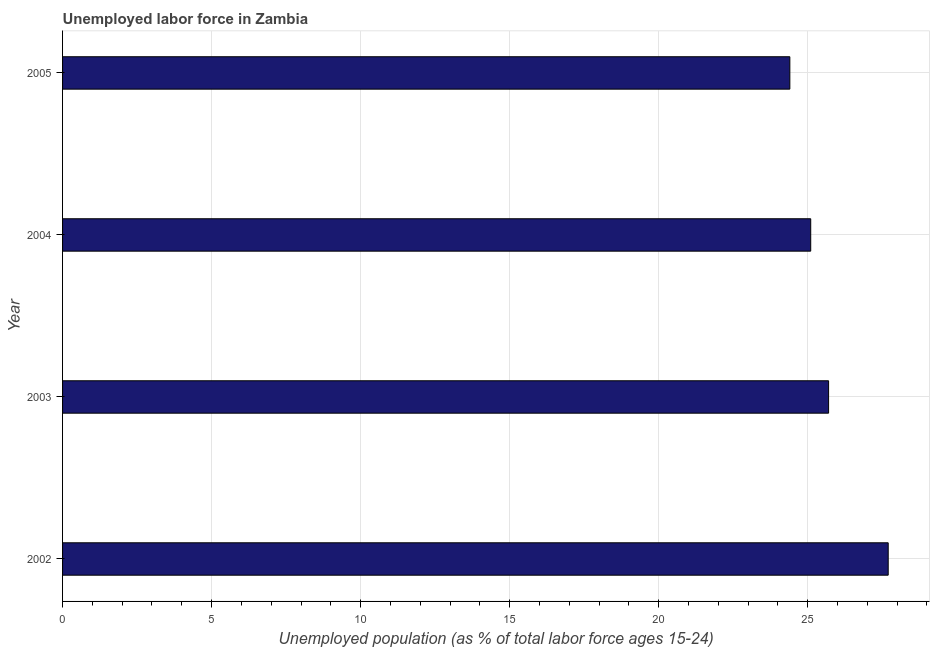Does the graph contain any zero values?
Give a very brief answer. No. What is the title of the graph?
Your response must be concise. Unemployed labor force in Zambia. What is the label or title of the X-axis?
Your answer should be very brief. Unemployed population (as % of total labor force ages 15-24). What is the total unemployed youth population in 2004?
Your answer should be compact. 25.1. Across all years, what is the maximum total unemployed youth population?
Make the answer very short. 27.7. Across all years, what is the minimum total unemployed youth population?
Offer a terse response. 24.4. What is the sum of the total unemployed youth population?
Your answer should be very brief. 102.9. What is the average total unemployed youth population per year?
Provide a succinct answer. 25.73. What is the median total unemployed youth population?
Your answer should be compact. 25.4. Do a majority of the years between 2002 and 2004 (inclusive) have total unemployed youth population greater than 19 %?
Provide a short and direct response. Yes. Is the difference between the total unemployed youth population in 2003 and 2004 greater than the difference between any two years?
Keep it short and to the point. No. Is the sum of the total unemployed youth population in 2002 and 2005 greater than the maximum total unemployed youth population across all years?
Your answer should be very brief. Yes. What is the difference between the highest and the lowest total unemployed youth population?
Your response must be concise. 3.3. How many bars are there?
Provide a short and direct response. 4. How many years are there in the graph?
Provide a succinct answer. 4. What is the Unemployed population (as % of total labor force ages 15-24) of 2002?
Give a very brief answer. 27.7. What is the Unemployed population (as % of total labor force ages 15-24) in 2003?
Ensure brevity in your answer.  25.7. What is the Unemployed population (as % of total labor force ages 15-24) of 2004?
Keep it short and to the point. 25.1. What is the Unemployed population (as % of total labor force ages 15-24) in 2005?
Provide a succinct answer. 24.4. What is the difference between the Unemployed population (as % of total labor force ages 15-24) in 2002 and 2004?
Offer a terse response. 2.6. What is the difference between the Unemployed population (as % of total labor force ages 15-24) in 2002 and 2005?
Provide a short and direct response. 3.3. What is the difference between the Unemployed population (as % of total labor force ages 15-24) in 2003 and 2005?
Offer a terse response. 1.3. What is the difference between the Unemployed population (as % of total labor force ages 15-24) in 2004 and 2005?
Provide a short and direct response. 0.7. What is the ratio of the Unemployed population (as % of total labor force ages 15-24) in 2002 to that in 2003?
Your response must be concise. 1.08. What is the ratio of the Unemployed population (as % of total labor force ages 15-24) in 2002 to that in 2004?
Ensure brevity in your answer.  1.1. What is the ratio of the Unemployed population (as % of total labor force ages 15-24) in 2002 to that in 2005?
Provide a succinct answer. 1.14. What is the ratio of the Unemployed population (as % of total labor force ages 15-24) in 2003 to that in 2005?
Your answer should be compact. 1.05. What is the ratio of the Unemployed population (as % of total labor force ages 15-24) in 2004 to that in 2005?
Keep it short and to the point. 1.03. 